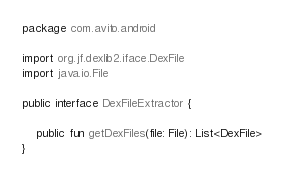<code> <loc_0><loc_0><loc_500><loc_500><_Kotlin_>package com.avito.android

import org.jf.dexlib2.iface.DexFile
import java.io.File

public interface DexFileExtractor {

    public fun getDexFiles(file: File): List<DexFile>
}
</code> 